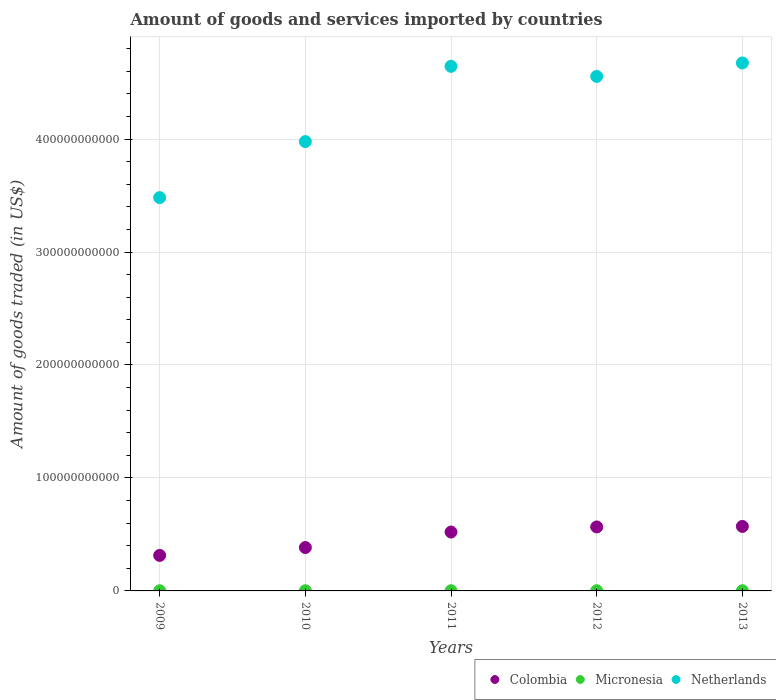How many different coloured dotlines are there?
Ensure brevity in your answer.  3. Is the number of dotlines equal to the number of legend labels?
Provide a succinct answer. Yes. What is the total amount of goods and services imported in Colombia in 2010?
Offer a terse response. 3.84e+1. Across all years, what is the maximum total amount of goods and services imported in Micronesia?
Give a very brief answer. 1.83e+08. Across all years, what is the minimum total amount of goods and services imported in Colombia?
Offer a terse response. 3.14e+1. In which year was the total amount of goods and services imported in Micronesia minimum?
Ensure brevity in your answer.  2009. What is the total total amount of goods and services imported in Netherlands in the graph?
Make the answer very short. 2.13e+12. What is the difference between the total amount of goods and services imported in Colombia in 2009 and that in 2011?
Offer a very short reply. -2.07e+1. What is the difference between the total amount of goods and services imported in Colombia in 2011 and the total amount of goods and services imported in Micronesia in 2013?
Offer a terse response. 5.19e+1. What is the average total amount of goods and services imported in Colombia per year?
Your answer should be very brief. 4.71e+1. In the year 2010, what is the difference between the total amount of goods and services imported in Colombia and total amount of goods and services imported in Micronesia?
Give a very brief answer. 3.82e+1. What is the ratio of the total amount of goods and services imported in Netherlands in 2009 to that in 2013?
Offer a very short reply. 0.74. What is the difference between the highest and the second highest total amount of goods and services imported in Colombia?
Provide a short and direct response. 4.53e+08. What is the difference between the highest and the lowest total amount of goods and services imported in Micronesia?
Keep it short and to the point. 2.98e+07. Is the sum of the total amount of goods and services imported in Netherlands in 2009 and 2013 greater than the maximum total amount of goods and services imported in Colombia across all years?
Provide a succinct answer. Yes. Is it the case that in every year, the sum of the total amount of goods and services imported in Colombia and total amount of goods and services imported in Netherlands  is greater than the total amount of goods and services imported in Micronesia?
Keep it short and to the point. Yes. Is the total amount of goods and services imported in Micronesia strictly less than the total amount of goods and services imported in Colombia over the years?
Provide a succinct answer. Yes. How many dotlines are there?
Give a very brief answer. 3. How many years are there in the graph?
Your response must be concise. 5. What is the difference between two consecutive major ticks on the Y-axis?
Provide a succinct answer. 1.00e+11. Are the values on the major ticks of Y-axis written in scientific E-notation?
Give a very brief answer. No. Does the graph contain any zero values?
Your answer should be compact. No. How many legend labels are there?
Your answer should be very brief. 3. What is the title of the graph?
Make the answer very short. Amount of goods and services imported by countries. Does "Ghana" appear as one of the legend labels in the graph?
Make the answer very short. No. What is the label or title of the X-axis?
Give a very brief answer. Years. What is the label or title of the Y-axis?
Provide a short and direct response. Amount of goods traded (in US$). What is the Amount of goods traded (in US$) of Colombia in 2009?
Your answer should be compact. 3.14e+1. What is the Amount of goods traded (in US$) in Micronesia in 2009?
Make the answer very short. 1.53e+08. What is the Amount of goods traded (in US$) in Netherlands in 2009?
Offer a terse response. 3.48e+11. What is the Amount of goods traded (in US$) in Colombia in 2010?
Offer a terse response. 3.84e+1. What is the Amount of goods traded (in US$) in Micronesia in 2010?
Ensure brevity in your answer.  1.60e+08. What is the Amount of goods traded (in US$) of Netherlands in 2010?
Provide a succinct answer. 3.98e+11. What is the Amount of goods traded (in US$) of Colombia in 2011?
Offer a terse response. 5.21e+1. What is the Amount of goods traded (in US$) of Micronesia in 2011?
Ensure brevity in your answer.  1.74e+08. What is the Amount of goods traded (in US$) in Netherlands in 2011?
Your response must be concise. 4.64e+11. What is the Amount of goods traded (in US$) in Colombia in 2012?
Your response must be concise. 5.66e+1. What is the Amount of goods traded (in US$) in Micronesia in 2012?
Keep it short and to the point. 1.83e+08. What is the Amount of goods traded (in US$) in Netherlands in 2012?
Offer a terse response. 4.55e+11. What is the Amount of goods traded (in US$) of Colombia in 2013?
Offer a terse response. 5.71e+1. What is the Amount of goods traded (in US$) in Micronesia in 2013?
Offer a very short reply. 1.79e+08. What is the Amount of goods traded (in US$) in Netherlands in 2013?
Provide a short and direct response. 4.67e+11. Across all years, what is the maximum Amount of goods traded (in US$) in Colombia?
Your response must be concise. 5.71e+1. Across all years, what is the maximum Amount of goods traded (in US$) in Micronesia?
Ensure brevity in your answer.  1.83e+08. Across all years, what is the maximum Amount of goods traded (in US$) of Netherlands?
Provide a succinct answer. 4.67e+11. Across all years, what is the minimum Amount of goods traded (in US$) in Colombia?
Offer a very short reply. 3.14e+1. Across all years, what is the minimum Amount of goods traded (in US$) of Micronesia?
Offer a terse response. 1.53e+08. Across all years, what is the minimum Amount of goods traded (in US$) of Netherlands?
Provide a short and direct response. 3.48e+11. What is the total Amount of goods traded (in US$) of Colombia in the graph?
Offer a very short reply. 2.36e+11. What is the total Amount of goods traded (in US$) in Micronesia in the graph?
Give a very brief answer. 8.50e+08. What is the total Amount of goods traded (in US$) in Netherlands in the graph?
Make the answer very short. 2.13e+12. What is the difference between the Amount of goods traded (in US$) of Colombia in 2009 and that in 2010?
Offer a very short reply. -6.98e+09. What is the difference between the Amount of goods traded (in US$) of Micronesia in 2009 and that in 2010?
Provide a succinct answer. -6.59e+06. What is the difference between the Amount of goods traded (in US$) of Netherlands in 2009 and that in 2010?
Your answer should be very brief. -4.96e+1. What is the difference between the Amount of goods traded (in US$) in Colombia in 2009 and that in 2011?
Ensure brevity in your answer.  -2.07e+1. What is the difference between the Amount of goods traded (in US$) in Micronesia in 2009 and that in 2011?
Make the answer very short. -2.10e+07. What is the difference between the Amount of goods traded (in US$) in Netherlands in 2009 and that in 2011?
Keep it short and to the point. -1.16e+11. What is the difference between the Amount of goods traded (in US$) of Colombia in 2009 and that in 2012?
Provide a short and direct response. -2.52e+1. What is the difference between the Amount of goods traded (in US$) of Micronesia in 2009 and that in 2012?
Keep it short and to the point. -2.98e+07. What is the difference between the Amount of goods traded (in US$) of Netherlands in 2009 and that in 2012?
Provide a short and direct response. -1.07e+11. What is the difference between the Amount of goods traded (in US$) in Colombia in 2009 and that in 2013?
Ensure brevity in your answer.  -2.57e+1. What is the difference between the Amount of goods traded (in US$) of Micronesia in 2009 and that in 2013?
Keep it short and to the point. -2.55e+07. What is the difference between the Amount of goods traded (in US$) of Netherlands in 2009 and that in 2013?
Give a very brief answer. -1.19e+11. What is the difference between the Amount of goods traded (in US$) in Colombia in 2010 and that in 2011?
Your response must be concise. -1.37e+1. What is the difference between the Amount of goods traded (in US$) of Micronesia in 2010 and that in 2011?
Provide a short and direct response. -1.44e+07. What is the difference between the Amount of goods traded (in US$) in Netherlands in 2010 and that in 2011?
Your answer should be very brief. -6.66e+1. What is the difference between the Amount of goods traded (in US$) in Colombia in 2010 and that in 2012?
Your answer should be compact. -1.82e+1. What is the difference between the Amount of goods traded (in US$) of Micronesia in 2010 and that in 2012?
Provide a short and direct response. -2.32e+07. What is the difference between the Amount of goods traded (in US$) of Netherlands in 2010 and that in 2012?
Provide a succinct answer. -5.77e+1. What is the difference between the Amount of goods traded (in US$) in Colombia in 2010 and that in 2013?
Keep it short and to the point. -1.87e+1. What is the difference between the Amount of goods traded (in US$) of Micronesia in 2010 and that in 2013?
Offer a very short reply. -1.89e+07. What is the difference between the Amount of goods traded (in US$) of Netherlands in 2010 and that in 2013?
Ensure brevity in your answer.  -6.96e+1. What is the difference between the Amount of goods traded (in US$) in Colombia in 2011 and that in 2012?
Give a very brief answer. -4.52e+09. What is the difference between the Amount of goods traded (in US$) of Micronesia in 2011 and that in 2012?
Provide a succinct answer. -8.79e+06. What is the difference between the Amount of goods traded (in US$) of Netherlands in 2011 and that in 2012?
Give a very brief answer. 8.93e+09. What is the difference between the Amount of goods traded (in US$) in Colombia in 2011 and that in 2013?
Your answer should be compact. -4.98e+09. What is the difference between the Amount of goods traded (in US$) of Micronesia in 2011 and that in 2013?
Offer a terse response. -4.51e+06. What is the difference between the Amount of goods traded (in US$) in Netherlands in 2011 and that in 2013?
Keep it short and to the point. -2.98e+09. What is the difference between the Amount of goods traded (in US$) in Colombia in 2012 and that in 2013?
Offer a very short reply. -4.53e+08. What is the difference between the Amount of goods traded (in US$) in Micronesia in 2012 and that in 2013?
Ensure brevity in your answer.  4.27e+06. What is the difference between the Amount of goods traded (in US$) in Netherlands in 2012 and that in 2013?
Provide a short and direct response. -1.19e+1. What is the difference between the Amount of goods traded (in US$) of Colombia in 2009 and the Amount of goods traded (in US$) of Micronesia in 2010?
Provide a short and direct response. 3.13e+1. What is the difference between the Amount of goods traded (in US$) of Colombia in 2009 and the Amount of goods traded (in US$) of Netherlands in 2010?
Keep it short and to the point. -3.66e+11. What is the difference between the Amount of goods traded (in US$) in Micronesia in 2009 and the Amount of goods traded (in US$) in Netherlands in 2010?
Your response must be concise. -3.98e+11. What is the difference between the Amount of goods traded (in US$) of Colombia in 2009 and the Amount of goods traded (in US$) of Micronesia in 2011?
Keep it short and to the point. 3.13e+1. What is the difference between the Amount of goods traded (in US$) in Colombia in 2009 and the Amount of goods traded (in US$) in Netherlands in 2011?
Offer a very short reply. -4.33e+11. What is the difference between the Amount of goods traded (in US$) in Micronesia in 2009 and the Amount of goods traded (in US$) in Netherlands in 2011?
Give a very brief answer. -4.64e+11. What is the difference between the Amount of goods traded (in US$) of Colombia in 2009 and the Amount of goods traded (in US$) of Micronesia in 2012?
Offer a terse response. 3.12e+1. What is the difference between the Amount of goods traded (in US$) in Colombia in 2009 and the Amount of goods traded (in US$) in Netherlands in 2012?
Your answer should be very brief. -4.24e+11. What is the difference between the Amount of goods traded (in US$) of Micronesia in 2009 and the Amount of goods traded (in US$) of Netherlands in 2012?
Offer a very short reply. -4.55e+11. What is the difference between the Amount of goods traded (in US$) of Colombia in 2009 and the Amount of goods traded (in US$) of Micronesia in 2013?
Your response must be concise. 3.12e+1. What is the difference between the Amount of goods traded (in US$) in Colombia in 2009 and the Amount of goods traded (in US$) in Netherlands in 2013?
Provide a succinct answer. -4.36e+11. What is the difference between the Amount of goods traded (in US$) of Micronesia in 2009 and the Amount of goods traded (in US$) of Netherlands in 2013?
Your response must be concise. -4.67e+11. What is the difference between the Amount of goods traded (in US$) of Colombia in 2010 and the Amount of goods traded (in US$) of Micronesia in 2011?
Give a very brief answer. 3.82e+1. What is the difference between the Amount of goods traded (in US$) in Colombia in 2010 and the Amount of goods traded (in US$) in Netherlands in 2011?
Your answer should be compact. -4.26e+11. What is the difference between the Amount of goods traded (in US$) of Micronesia in 2010 and the Amount of goods traded (in US$) of Netherlands in 2011?
Your answer should be compact. -4.64e+11. What is the difference between the Amount of goods traded (in US$) in Colombia in 2010 and the Amount of goods traded (in US$) in Micronesia in 2012?
Provide a short and direct response. 3.82e+1. What is the difference between the Amount of goods traded (in US$) in Colombia in 2010 and the Amount of goods traded (in US$) in Netherlands in 2012?
Ensure brevity in your answer.  -4.17e+11. What is the difference between the Amount of goods traded (in US$) of Micronesia in 2010 and the Amount of goods traded (in US$) of Netherlands in 2012?
Your answer should be very brief. -4.55e+11. What is the difference between the Amount of goods traded (in US$) of Colombia in 2010 and the Amount of goods traded (in US$) of Micronesia in 2013?
Keep it short and to the point. 3.82e+1. What is the difference between the Amount of goods traded (in US$) of Colombia in 2010 and the Amount of goods traded (in US$) of Netherlands in 2013?
Provide a short and direct response. -4.29e+11. What is the difference between the Amount of goods traded (in US$) of Micronesia in 2010 and the Amount of goods traded (in US$) of Netherlands in 2013?
Provide a short and direct response. -4.67e+11. What is the difference between the Amount of goods traded (in US$) in Colombia in 2011 and the Amount of goods traded (in US$) in Micronesia in 2012?
Provide a short and direct response. 5.19e+1. What is the difference between the Amount of goods traded (in US$) of Colombia in 2011 and the Amount of goods traded (in US$) of Netherlands in 2012?
Offer a terse response. -4.03e+11. What is the difference between the Amount of goods traded (in US$) of Micronesia in 2011 and the Amount of goods traded (in US$) of Netherlands in 2012?
Your answer should be compact. -4.55e+11. What is the difference between the Amount of goods traded (in US$) in Colombia in 2011 and the Amount of goods traded (in US$) in Micronesia in 2013?
Your answer should be very brief. 5.19e+1. What is the difference between the Amount of goods traded (in US$) in Colombia in 2011 and the Amount of goods traded (in US$) in Netherlands in 2013?
Your answer should be very brief. -4.15e+11. What is the difference between the Amount of goods traded (in US$) in Micronesia in 2011 and the Amount of goods traded (in US$) in Netherlands in 2013?
Your answer should be compact. -4.67e+11. What is the difference between the Amount of goods traded (in US$) of Colombia in 2012 and the Amount of goods traded (in US$) of Micronesia in 2013?
Ensure brevity in your answer.  5.65e+1. What is the difference between the Amount of goods traded (in US$) of Colombia in 2012 and the Amount of goods traded (in US$) of Netherlands in 2013?
Give a very brief answer. -4.11e+11. What is the difference between the Amount of goods traded (in US$) in Micronesia in 2012 and the Amount of goods traded (in US$) in Netherlands in 2013?
Your answer should be compact. -4.67e+11. What is the average Amount of goods traded (in US$) in Colombia per year?
Ensure brevity in your answer.  4.71e+1. What is the average Amount of goods traded (in US$) of Micronesia per year?
Offer a terse response. 1.70e+08. What is the average Amount of goods traded (in US$) in Netherlands per year?
Your response must be concise. 4.27e+11. In the year 2009, what is the difference between the Amount of goods traded (in US$) in Colombia and Amount of goods traded (in US$) in Micronesia?
Offer a terse response. 3.13e+1. In the year 2009, what is the difference between the Amount of goods traded (in US$) of Colombia and Amount of goods traded (in US$) of Netherlands?
Offer a terse response. -3.17e+11. In the year 2009, what is the difference between the Amount of goods traded (in US$) of Micronesia and Amount of goods traded (in US$) of Netherlands?
Provide a succinct answer. -3.48e+11. In the year 2010, what is the difference between the Amount of goods traded (in US$) in Colombia and Amount of goods traded (in US$) in Micronesia?
Provide a succinct answer. 3.82e+1. In the year 2010, what is the difference between the Amount of goods traded (in US$) of Colombia and Amount of goods traded (in US$) of Netherlands?
Offer a very short reply. -3.59e+11. In the year 2010, what is the difference between the Amount of goods traded (in US$) of Micronesia and Amount of goods traded (in US$) of Netherlands?
Offer a terse response. -3.98e+11. In the year 2011, what is the difference between the Amount of goods traded (in US$) of Colombia and Amount of goods traded (in US$) of Micronesia?
Provide a succinct answer. 5.20e+1. In the year 2011, what is the difference between the Amount of goods traded (in US$) of Colombia and Amount of goods traded (in US$) of Netherlands?
Your answer should be very brief. -4.12e+11. In the year 2011, what is the difference between the Amount of goods traded (in US$) in Micronesia and Amount of goods traded (in US$) in Netherlands?
Offer a terse response. -4.64e+11. In the year 2012, what is the difference between the Amount of goods traded (in US$) in Colombia and Amount of goods traded (in US$) in Micronesia?
Offer a terse response. 5.65e+1. In the year 2012, what is the difference between the Amount of goods traded (in US$) in Colombia and Amount of goods traded (in US$) in Netherlands?
Give a very brief answer. -3.99e+11. In the year 2012, what is the difference between the Amount of goods traded (in US$) in Micronesia and Amount of goods traded (in US$) in Netherlands?
Give a very brief answer. -4.55e+11. In the year 2013, what is the difference between the Amount of goods traded (in US$) in Colombia and Amount of goods traded (in US$) in Micronesia?
Ensure brevity in your answer.  5.69e+1. In the year 2013, what is the difference between the Amount of goods traded (in US$) in Colombia and Amount of goods traded (in US$) in Netherlands?
Ensure brevity in your answer.  -4.10e+11. In the year 2013, what is the difference between the Amount of goods traded (in US$) in Micronesia and Amount of goods traded (in US$) in Netherlands?
Offer a terse response. -4.67e+11. What is the ratio of the Amount of goods traded (in US$) in Colombia in 2009 to that in 2010?
Provide a succinct answer. 0.82. What is the ratio of the Amount of goods traded (in US$) of Micronesia in 2009 to that in 2010?
Give a very brief answer. 0.96. What is the ratio of the Amount of goods traded (in US$) of Netherlands in 2009 to that in 2010?
Your answer should be very brief. 0.88. What is the ratio of the Amount of goods traded (in US$) in Colombia in 2009 to that in 2011?
Make the answer very short. 0.6. What is the ratio of the Amount of goods traded (in US$) of Micronesia in 2009 to that in 2011?
Offer a very short reply. 0.88. What is the ratio of the Amount of goods traded (in US$) in Netherlands in 2009 to that in 2011?
Provide a short and direct response. 0.75. What is the ratio of the Amount of goods traded (in US$) in Colombia in 2009 to that in 2012?
Ensure brevity in your answer.  0.55. What is the ratio of the Amount of goods traded (in US$) of Micronesia in 2009 to that in 2012?
Ensure brevity in your answer.  0.84. What is the ratio of the Amount of goods traded (in US$) in Netherlands in 2009 to that in 2012?
Your response must be concise. 0.76. What is the ratio of the Amount of goods traded (in US$) in Colombia in 2009 to that in 2013?
Make the answer very short. 0.55. What is the ratio of the Amount of goods traded (in US$) in Micronesia in 2009 to that in 2013?
Ensure brevity in your answer.  0.86. What is the ratio of the Amount of goods traded (in US$) in Netherlands in 2009 to that in 2013?
Keep it short and to the point. 0.74. What is the ratio of the Amount of goods traded (in US$) in Colombia in 2010 to that in 2011?
Provide a succinct answer. 0.74. What is the ratio of the Amount of goods traded (in US$) of Micronesia in 2010 to that in 2011?
Make the answer very short. 0.92. What is the ratio of the Amount of goods traded (in US$) in Netherlands in 2010 to that in 2011?
Your response must be concise. 0.86. What is the ratio of the Amount of goods traded (in US$) of Colombia in 2010 to that in 2012?
Ensure brevity in your answer.  0.68. What is the ratio of the Amount of goods traded (in US$) in Micronesia in 2010 to that in 2012?
Offer a terse response. 0.87. What is the ratio of the Amount of goods traded (in US$) of Netherlands in 2010 to that in 2012?
Offer a very short reply. 0.87. What is the ratio of the Amount of goods traded (in US$) of Colombia in 2010 to that in 2013?
Your response must be concise. 0.67. What is the ratio of the Amount of goods traded (in US$) in Micronesia in 2010 to that in 2013?
Ensure brevity in your answer.  0.89. What is the ratio of the Amount of goods traded (in US$) of Netherlands in 2010 to that in 2013?
Offer a terse response. 0.85. What is the ratio of the Amount of goods traded (in US$) of Colombia in 2011 to that in 2012?
Offer a terse response. 0.92. What is the ratio of the Amount of goods traded (in US$) in Micronesia in 2011 to that in 2012?
Offer a very short reply. 0.95. What is the ratio of the Amount of goods traded (in US$) in Netherlands in 2011 to that in 2012?
Ensure brevity in your answer.  1.02. What is the ratio of the Amount of goods traded (in US$) of Colombia in 2011 to that in 2013?
Provide a succinct answer. 0.91. What is the ratio of the Amount of goods traded (in US$) in Micronesia in 2011 to that in 2013?
Your response must be concise. 0.97. What is the ratio of the Amount of goods traded (in US$) in Netherlands in 2011 to that in 2013?
Make the answer very short. 0.99. What is the ratio of the Amount of goods traded (in US$) of Micronesia in 2012 to that in 2013?
Offer a very short reply. 1.02. What is the ratio of the Amount of goods traded (in US$) in Netherlands in 2012 to that in 2013?
Keep it short and to the point. 0.97. What is the difference between the highest and the second highest Amount of goods traded (in US$) in Colombia?
Provide a short and direct response. 4.53e+08. What is the difference between the highest and the second highest Amount of goods traded (in US$) of Micronesia?
Give a very brief answer. 4.27e+06. What is the difference between the highest and the second highest Amount of goods traded (in US$) of Netherlands?
Provide a succinct answer. 2.98e+09. What is the difference between the highest and the lowest Amount of goods traded (in US$) of Colombia?
Offer a very short reply. 2.57e+1. What is the difference between the highest and the lowest Amount of goods traded (in US$) in Micronesia?
Ensure brevity in your answer.  2.98e+07. What is the difference between the highest and the lowest Amount of goods traded (in US$) in Netherlands?
Ensure brevity in your answer.  1.19e+11. 